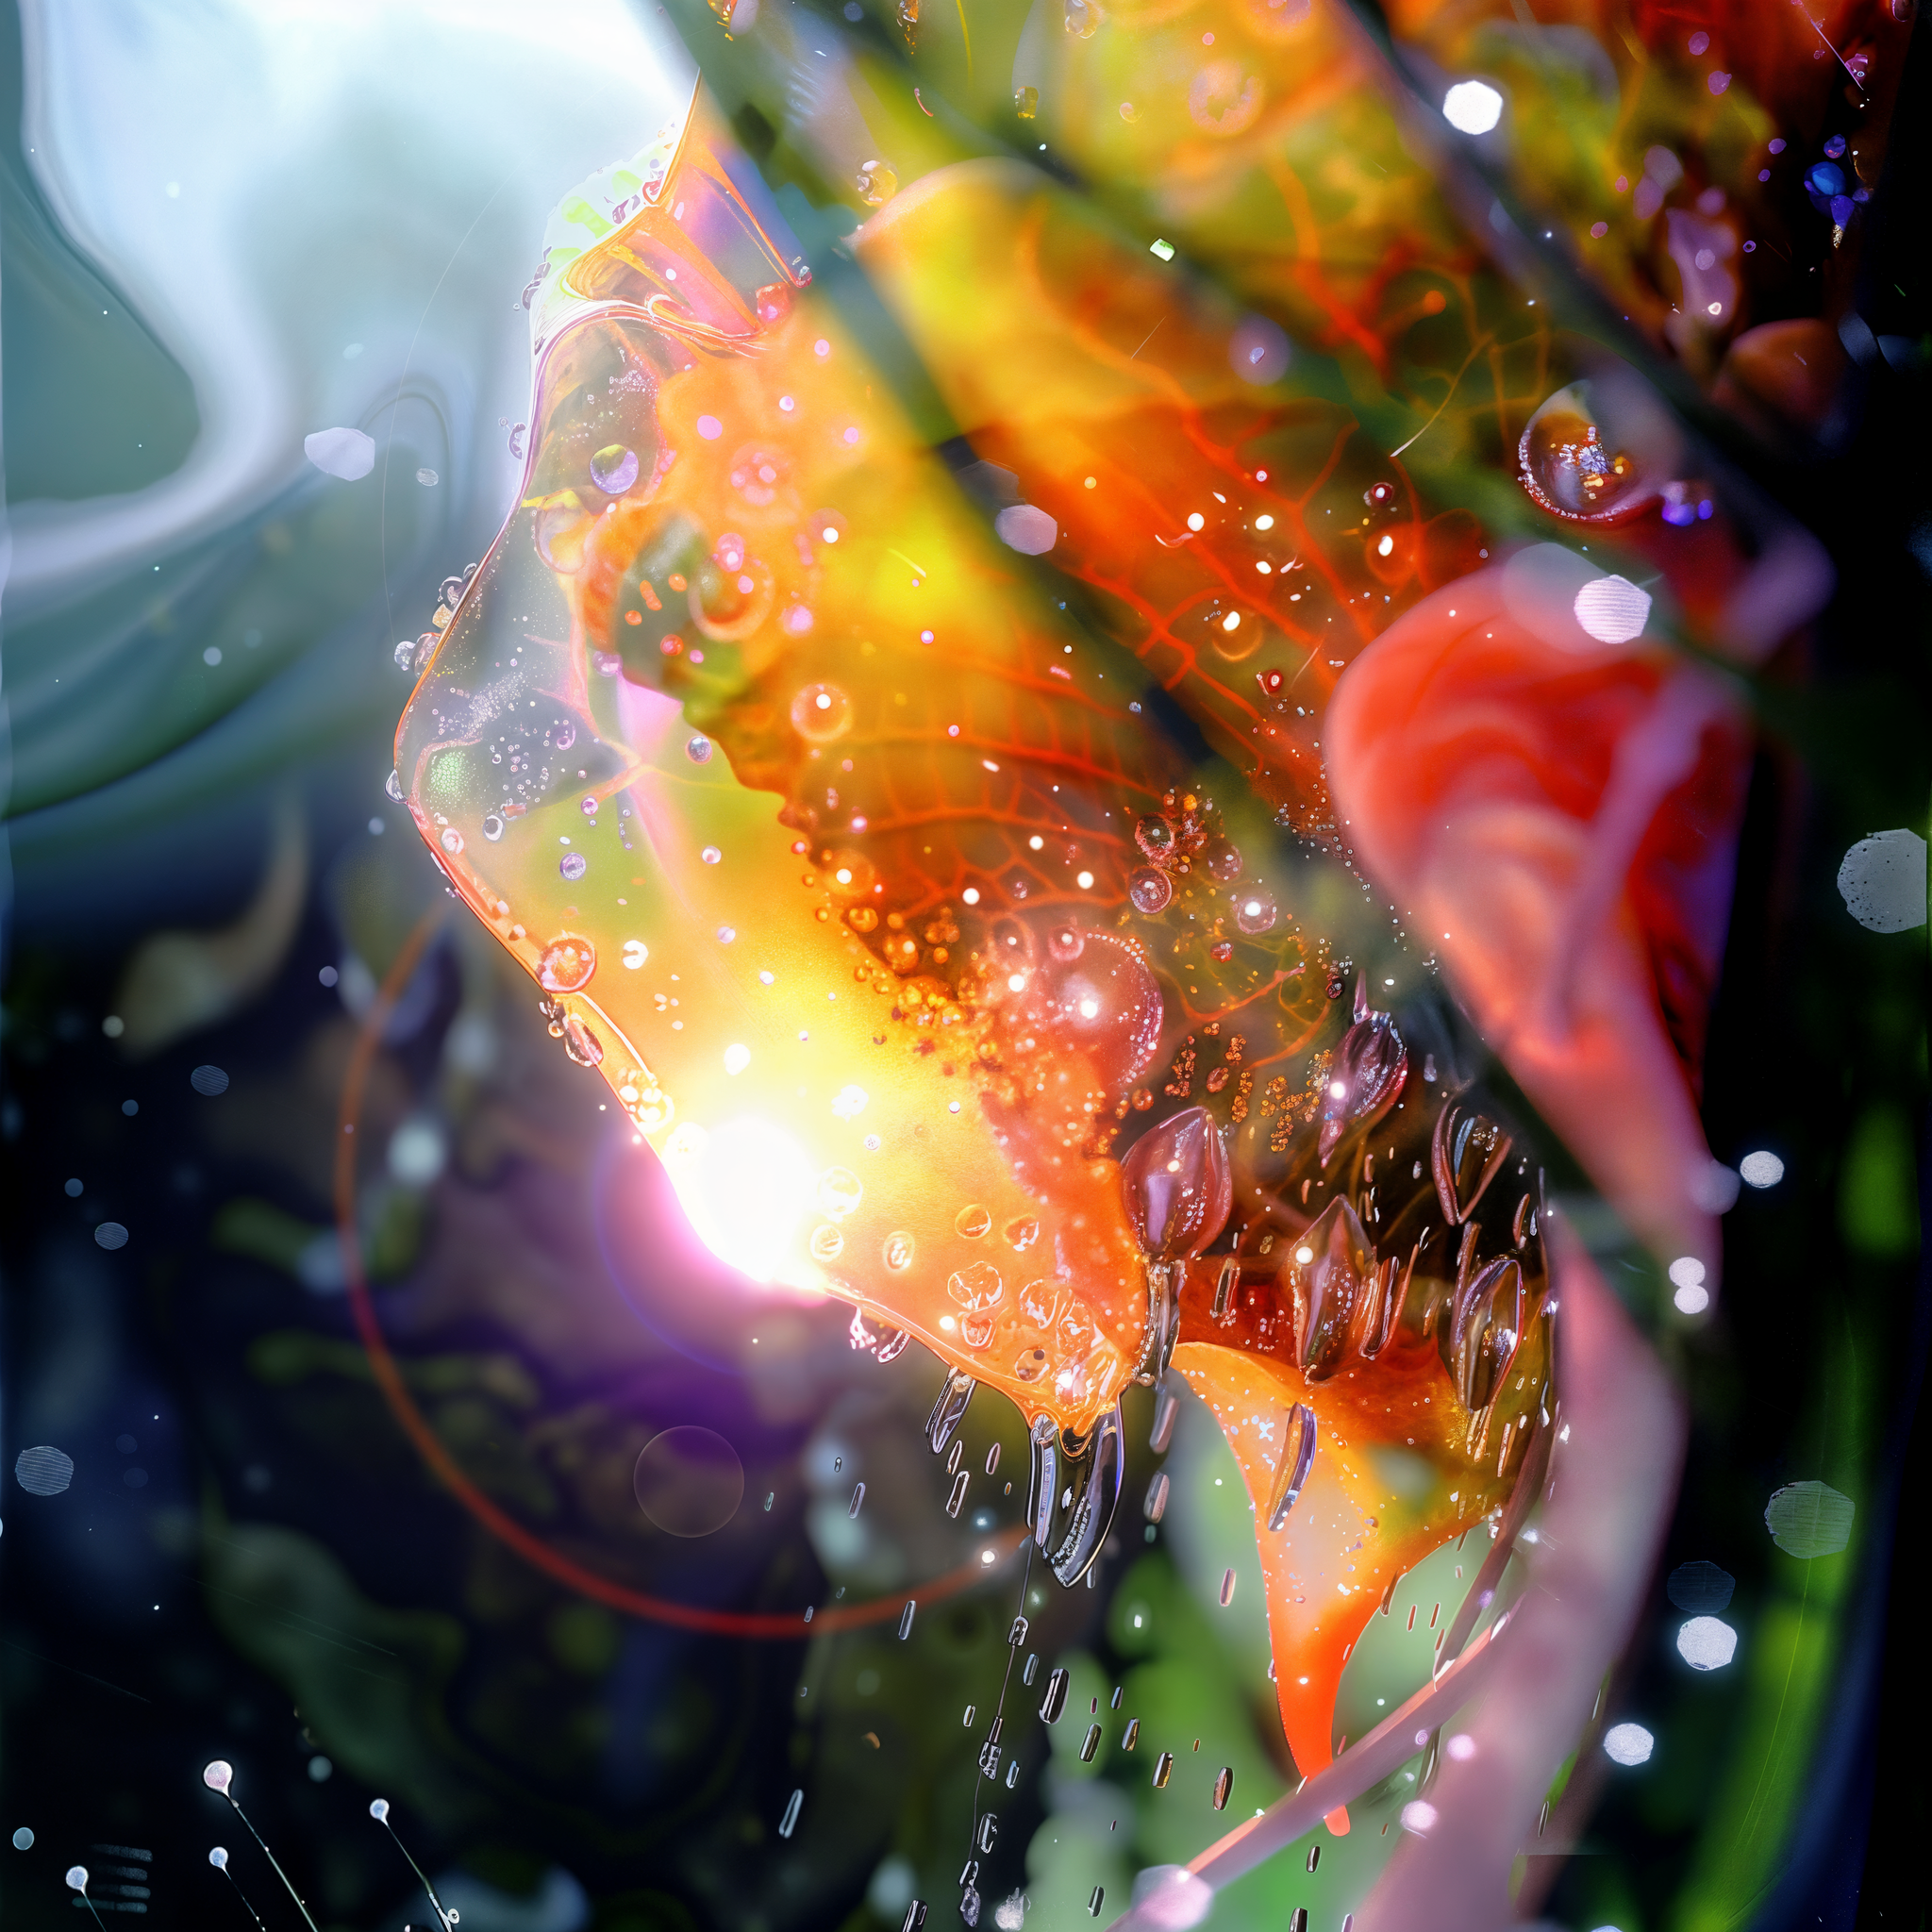describe th eimage The image is an abstract and vibrant close-up composition, featuring an array of bright and vivid colors. It seems to depict a macro shot of a liquid-filled or moisture-laden surface, possibly a flower petal or some organic material, with various elements like water droplets and bubbles.

Key features include:
- Dominant warm colors such as orange, yellow, and red.
- Light reflections and refractions creating a glowing effect.
- Presence of water droplets and bubbles, adding to the texture and depth.
- Some blurred and translucent areas, contributing to the abstract and dreamy feel.
- Background elements that are darker, providing contrast to the bright foreground.

The overall impression is dynamic and fluid, with a mix of natural and surreal elements. 